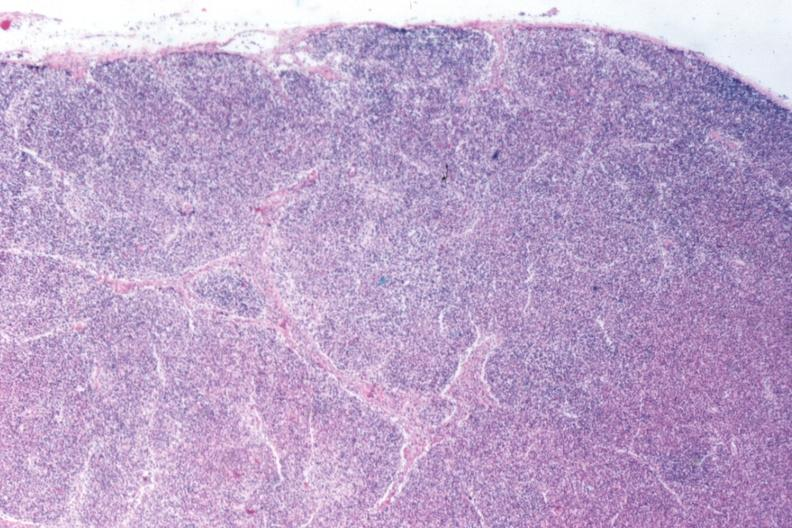what does this image show?
Answer the question using a single word or phrase. That total effacement case appears to have changed into a blast crisis 